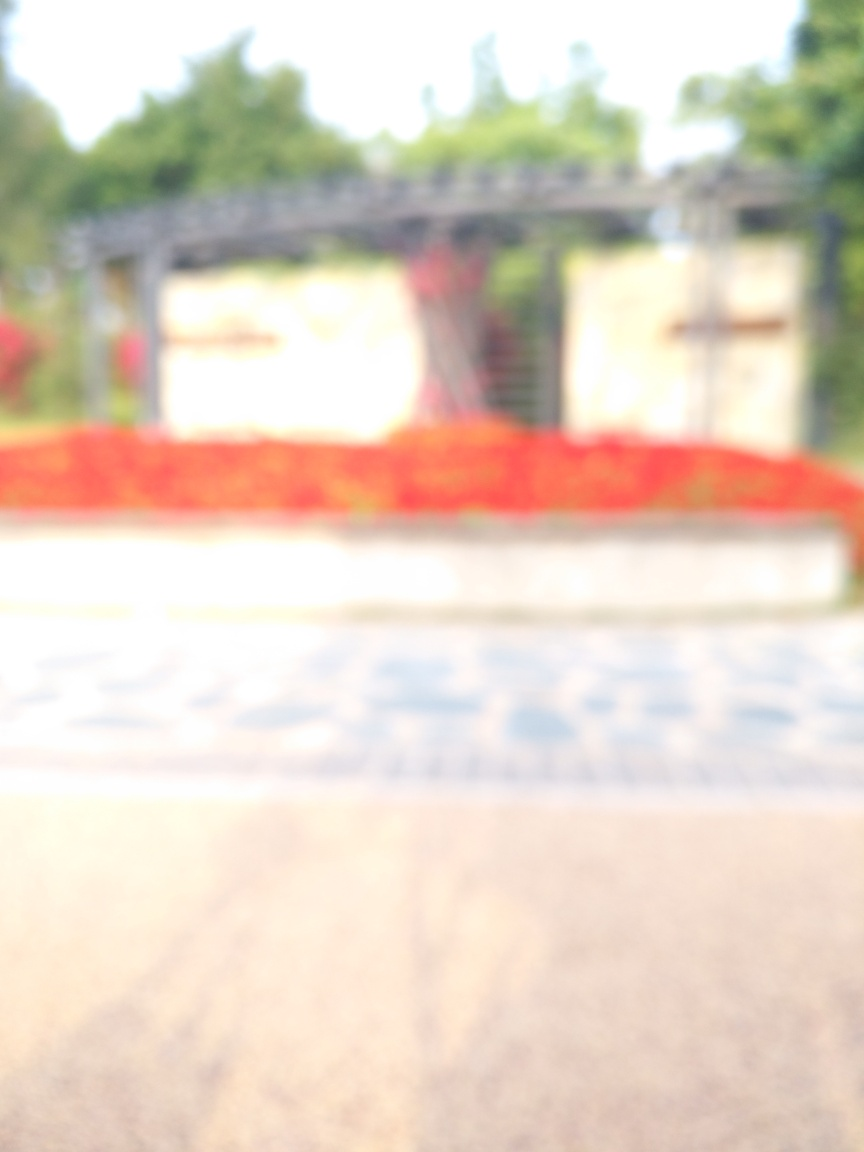Is the overall sharpness of the image low? Indeed, the image appears quite blurry, lacking in clear details and sharpness. This gives it an out-of-focus appearance, possibly due to camera movement during the shot, incorrect focus settings, or a deliberate artistic choice to convey a certain mood or atmosphere. 